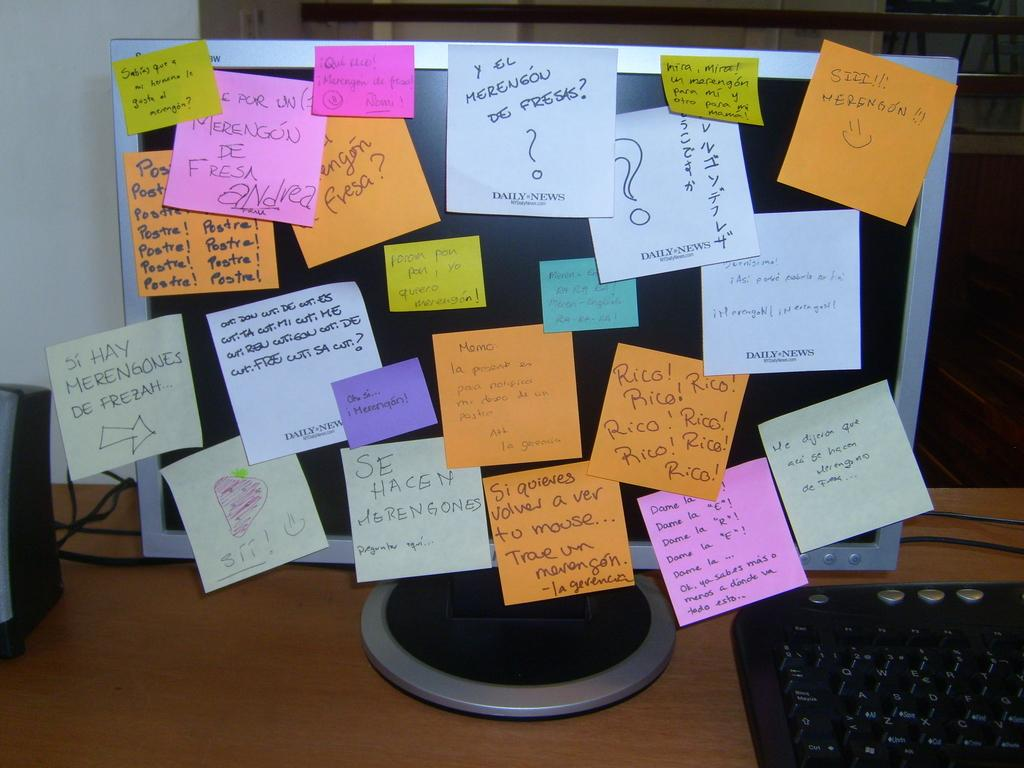<image>
Render a clear and concise summary of the photo. A computer screen is covered with sticky notes labeled memo, mira, mira, and others. 